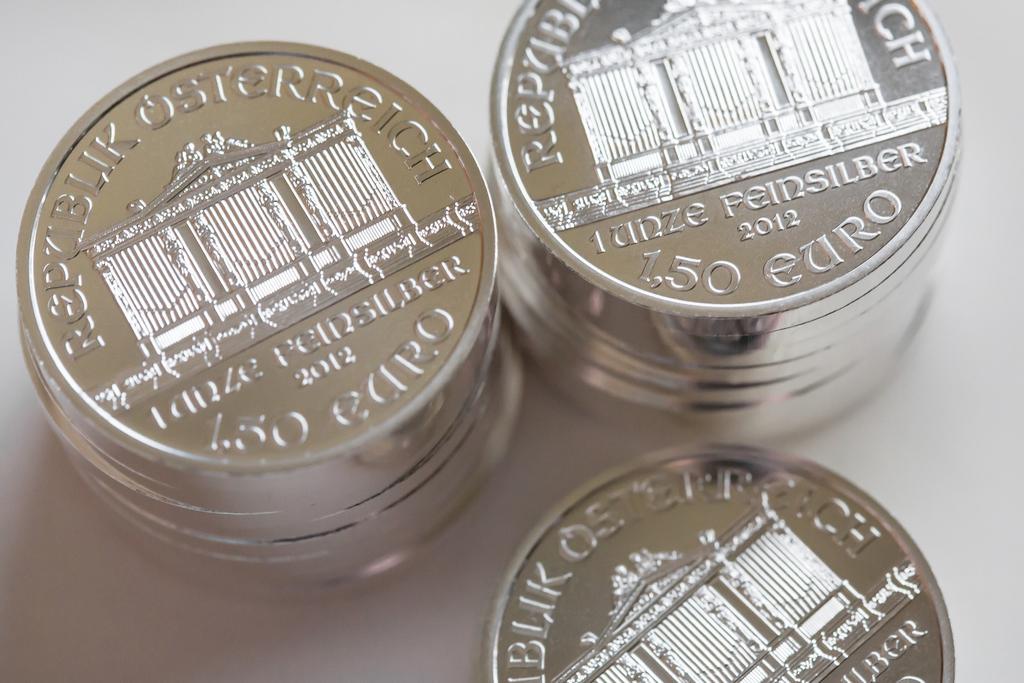What year were these coins made in?
Give a very brief answer. 2012. They are three coins?
Ensure brevity in your answer.  Yes. 